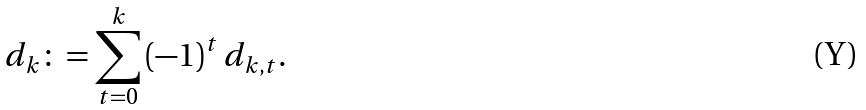Convert formula to latex. <formula><loc_0><loc_0><loc_500><loc_500>d _ { k } & \colon = \sum _ { t = 0 } ^ { k } \left ( - 1 \right ) ^ { t } d _ { k , t } .</formula> 